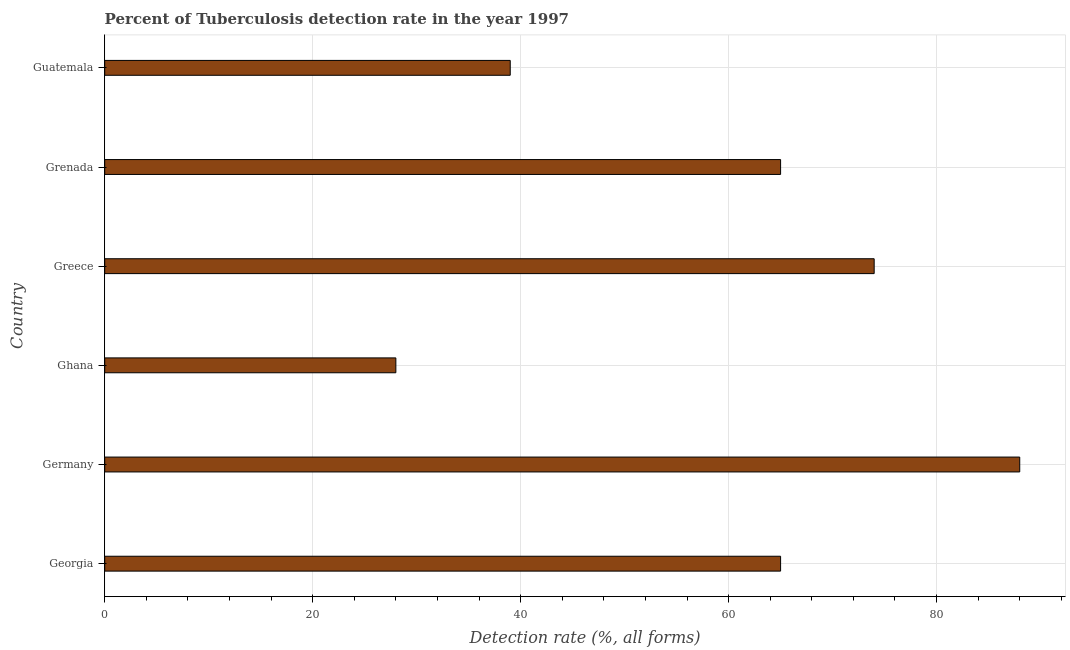What is the title of the graph?
Your response must be concise. Percent of Tuberculosis detection rate in the year 1997. What is the label or title of the X-axis?
Your answer should be very brief. Detection rate (%, all forms). What is the label or title of the Y-axis?
Give a very brief answer. Country. Across all countries, what is the maximum detection rate of tuberculosis?
Provide a short and direct response. 88. What is the sum of the detection rate of tuberculosis?
Your answer should be very brief. 359. What is the average detection rate of tuberculosis per country?
Your response must be concise. 59.83. What is the median detection rate of tuberculosis?
Keep it short and to the point. 65. In how many countries, is the detection rate of tuberculosis greater than 4 %?
Make the answer very short. 6. What is the ratio of the detection rate of tuberculosis in Germany to that in Greece?
Make the answer very short. 1.19. Is the detection rate of tuberculosis in Georgia less than that in Grenada?
Keep it short and to the point. No. What is the difference between the highest and the second highest detection rate of tuberculosis?
Provide a succinct answer. 14. Are all the bars in the graph horizontal?
Your answer should be compact. Yes. What is the Detection rate (%, all forms) of Grenada?
Offer a very short reply. 65. What is the Detection rate (%, all forms) of Guatemala?
Keep it short and to the point. 39. What is the difference between the Detection rate (%, all forms) in Georgia and Greece?
Provide a succinct answer. -9. What is the difference between the Detection rate (%, all forms) in Georgia and Grenada?
Your answer should be very brief. 0. What is the difference between the Detection rate (%, all forms) in Germany and Ghana?
Provide a short and direct response. 60. What is the difference between the Detection rate (%, all forms) in Germany and Greece?
Provide a succinct answer. 14. What is the difference between the Detection rate (%, all forms) in Germany and Guatemala?
Make the answer very short. 49. What is the difference between the Detection rate (%, all forms) in Ghana and Greece?
Your response must be concise. -46. What is the difference between the Detection rate (%, all forms) in Ghana and Grenada?
Ensure brevity in your answer.  -37. What is the difference between the Detection rate (%, all forms) in Greece and Grenada?
Your response must be concise. 9. What is the difference between the Detection rate (%, all forms) in Greece and Guatemala?
Provide a short and direct response. 35. What is the difference between the Detection rate (%, all forms) in Grenada and Guatemala?
Give a very brief answer. 26. What is the ratio of the Detection rate (%, all forms) in Georgia to that in Germany?
Offer a very short reply. 0.74. What is the ratio of the Detection rate (%, all forms) in Georgia to that in Ghana?
Provide a succinct answer. 2.32. What is the ratio of the Detection rate (%, all forms) in Georgia to that in Greece?
Offer a terse response. 0.88. What is the ratio of the Detection rate (%, all forms) in Georgia to that in Guatemala?
Offer a very short reply. 1.67. What is the ratio of the Detection rate (%, all forms) in Germany to that in Ghana?
Keep it short and to the point. 3.14. What is the ratio of the Detection rate (%, all forms) in Germany to that in Greece?
Your answer should be compact. 1.19. What is the ratio of the Detection rate (%, all forms) in Germany to that in Grenada?
Offer a terse response. 1.35. What is the ratio of the Detection rate (%, all forms) in Germany to that in Guatemala?
Keep it short and to the point. 2.26. What is the ratio of the Detection rate (%, all forms) in Ghana to that in Greece?
Keep it short and to the point. 0.38. What is the ratio of the Detection rate (%, all forms) in Ghana to that in Grenada?
Make the answer very short. 0.43. What is the ratio of the Detection rate (%, all forms) in Ghana to that in Guatemala?
Provide a short and direct response. 0.72. What is the ratio of the Detection rate (%, all forms) in Greece to that in Grenada?
Provide a short and direct response. 1.14. What is the ratio of the Detection rate (%, all forms) in Greece to that in Guatemala?
Ensure brevity in your answer.  1.9. What is the ratio of the Detection rate (%, all forms) in Grenada to that in Guatemala?
Your answer should be compact. 1.67. 